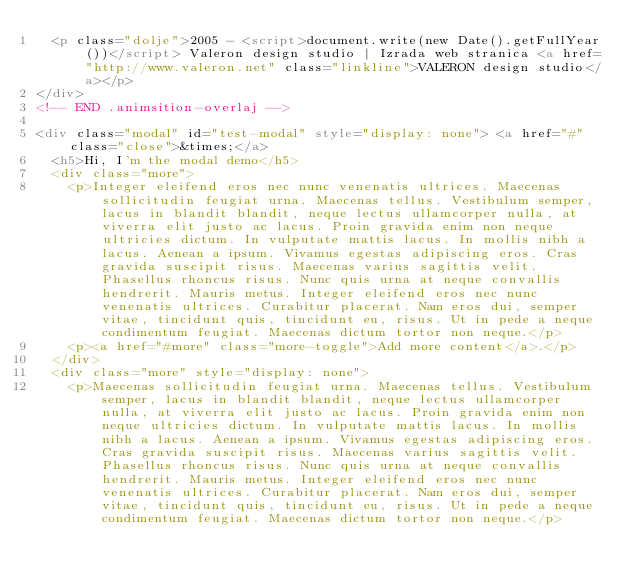Convert code to text. <code><loc_0><loc_0><loc_500><loc_500><_HTML_>  <p class="dolje">2005 - <script>document.write(new Date().getFullYear())</script> Valeron design studio | Izrada web stranica <a href="http://www.valeron.net" class="linkline">VALERON design studio</a></p>
</div>
<!-- END .animsition-overlaj -->

<div class="modal" id="test-modal" style="display: none"> <a href="#" class="close">&times;</a>
  <h5>Hi, I'm the modal demo</h5>
  <div class="more">
    <p>Integer eleifend eros nec nunc venenatis ultrices. Maecenas sollicitudin feugiat urna. Maecenas tellus. Vestibulum semper, lacus in blandit blandit, neque lectus ullamcorper nulla, at viverra elit justo ac lacus. Proin gravida enim non neque ultricies dictum. In vulputate mattis lacus. In mollis nibh a lacus. Aenean a ipsum. Vivamus egestas adipiscing eros. Cras gravida suscipit risus. Maecenas varius sagittis velit. Phasellus rhoncus risus. Nunc quis urna at neque convallis hendrerit. Mauris metus. Integer eleifend eros nec nunc venenatis ultrices. Curabitur placerat. Nam eros dui, semper vitae, tincidunt quis, tincidunt eu, risus. Ut in pede a neque condimentum feugiat. Maecenas dictum tortor non neque.</p>
    <p><a href="#more" class="more-toggle">Add more content</a>.</p>
  </div>
  <div class="more" style="display: none">
    <p>Maecenas sollicitudin feugiat urna. Maecenas tellus. Vestibulum semper, lacus in blandit blandit, neque lectus ullamcorper nulla, at viverra elit justo ac lacus. Proin gravida enim non neque ultricies dictum. In vulputate mattis lacus. In mollis nibh a lacus. Aenean a ipsum. Vivamus egestas adipiscing eros. Cras gravida suscipit risus. Maecenas varius sagittis velit. Phasellus rhoncus risus. Nunc quis urna at neque convallis hendrerit. Mauris metus. Integer eleifend eros nec nunc venenatis ultrices. Curabitur placerat. Nam eros dui, semper vitae, tincidunt quis, tincidunt eu, risus. Ut in pede a neque condimentum feugiat. Maecenas dictum tortor non neque.</p></code> 